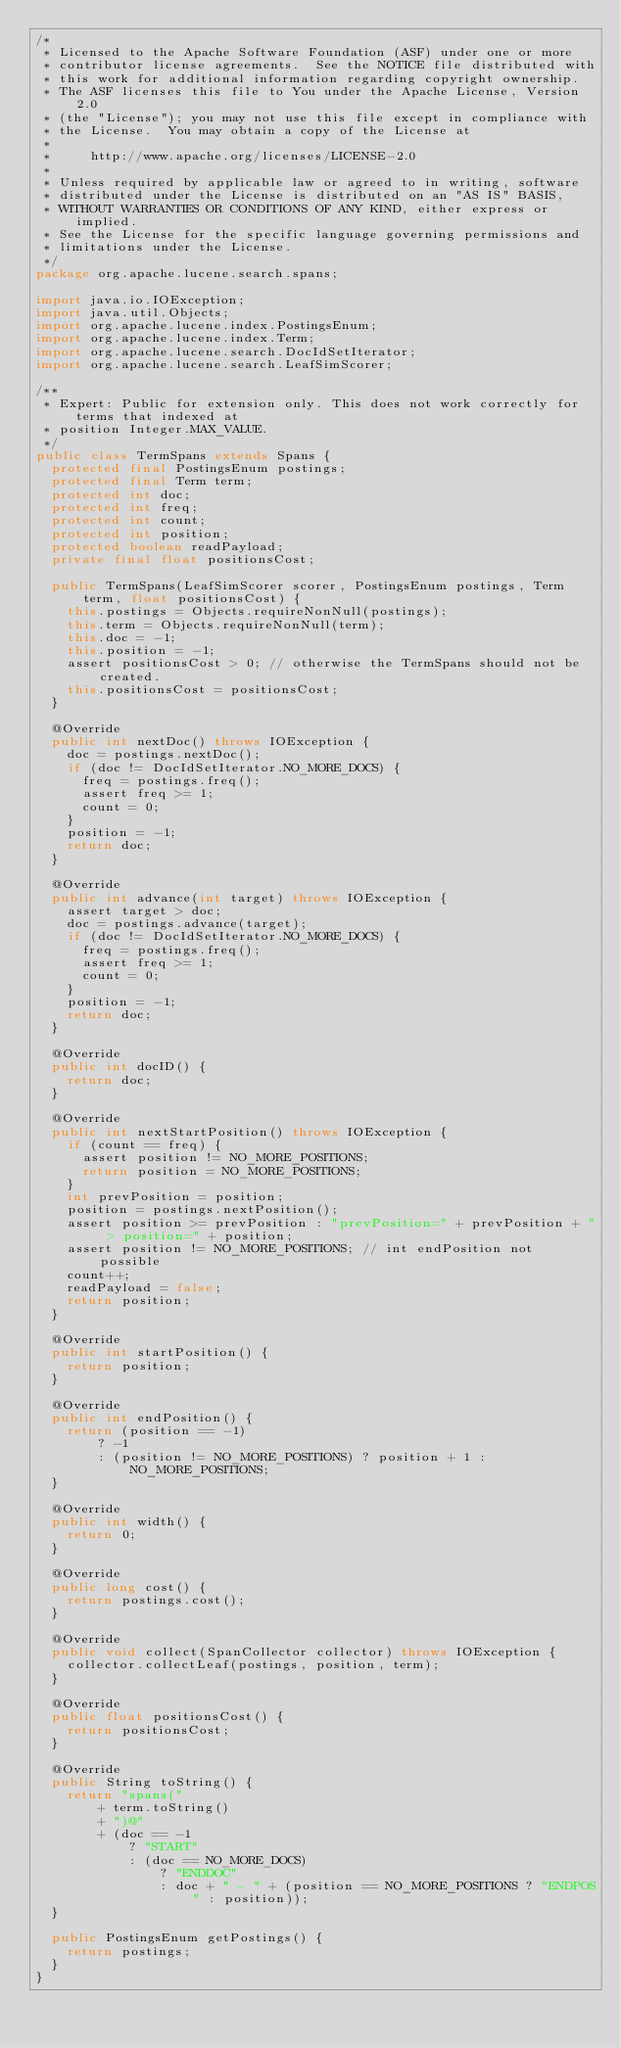Convert code to text. <code><loc_0><loc_0><loc_500><loc_500><_Java_>/*
 * Licensed to the Apache Software Foundation (ASF) under one or more
 * contributor license agreements.  See the NOTICE file distributed with
 * this work for additional information regarding copyright ownership.
 * The ASF licenses this file to You under the Apache License, Version 2.0
 * (the "License"); you may not use this file except in compliance with
 * the License.  You may obtain a copy of the License at
 *
 *     http://www.apache.org/licenses/LICENSE-2.0
 *
 * Unless required by applicable law or agreed to in writing, software
 * distributed under the License is distributed on an "AS IS" BASIS,
 * WITHOUT WARRANTIES OR CONDITIONS OF ANY KIND, either express or implied.
 * See the License for the specific language governing permissions and
 * limitations under the License.
 */
package org.apache.lucene.search.spans;

import java.io.IOException;
import java.util.Objects;
import org.apache.lucene.index.PostingsEnum;
import org.apache.lucene.index.Term;
import org.apache.lucene.search.DocIdSetIterator;
import org.apache.lucene.search.LeafSimScorer;

/**
 * Expert: Public for extension only. This does not work correctly for terms that indexed at
 * position Integer.MAX_VALUE.
 */
public class TermSpans extends Spans {
  protected final PostingsEnum postings;
  protected final Term term;
  protected int doc;
  protected int freq;
  protected int count;
  protected int position;
  protected boolean readPayload;
  private final float positionsCost;

  public TermSpans(LeafSimScorer scorer, PostingsEnum postings, Term term, float positionsCost) {
    this.postings = Objects.requireNonNull(postings);
    this.term = Objects.requireNonNull(term);
    this.doc = -1;
    this.position = -1;
    assert positionsCost > 0; // otherwise the TermSpans should not be created.
    this.positionsCost = positionsCost;
  }

  @Override
  public int nextDoc() throws IOException {
    doc = postings.nextDoc();
    if (doc != DocIdSetIterator.NO_MORE_DOCS) {
      freq = postings.freq();
      assert freq >= 1;
      count = 0;
    }
    position = -1;
    return doc;
  }

  @Override
  public int advance(int target) throws IOException {
    assert target > doc;
    doc = postings.advance(target);
    if (doc != DocIdSetIterator.NO_MORE_DOCS) {
      freq = postings.freq();
      assert freq >= 1;
      count = 0;
    }
    position = -1;
    return doc;
  }

  @Override
  public int docID() {
    return doc;
  }

  @Override
  public int nextStartPosition() throws IOException {
    if (count == freq) {
      assert position != NO_MORE_POSITIONS;
      return position = NO_MORE_POSITIONS;
    }
    int prevPosition = position;
    position = postings.nextPosition();
    assert position >= prevPosition : "prevPosition=" + prevPosition + " > position=" + position;
    assert position != NO_MORE_POSITIONS; // int endPosition not possible
    count++;
    readPayload = false;
    return position;
  }

  @Override
  public int startPosition() {
    return position;
  }

  @Override
  public int endPosition() {
    return (position == -1)
        ? -1
        : (position != NO_MORE_POSITIONS) ? position + 1 : NO_MORE_POSITIONS;
  }

  @Override
  public int width() {
    return 0;
  }

  @Override
  public long cost() {
    return postings.cost();
  }

  @Override
  public void collect(SpanCollector collector) throws IOException {
    collector.collectLeaf(postings, position, term);
  }

  @Override
  public float positionsCost() {
    return positionsCost;
  }

  @Override
  public String toString() {
    return "spans("
        + term.toString()
        + ")@"
        + (doc == -1
            ? "START"
            : (doc == NO_MORE_DOCS)
                ? "ENDDOC"
                : doc + " - " + (position == NO_MORE_POSITIONS ? "ENDPOS" : position));
  }

  public PostingsEnum getPostings() {
    return postings;
  }
}
</code> 